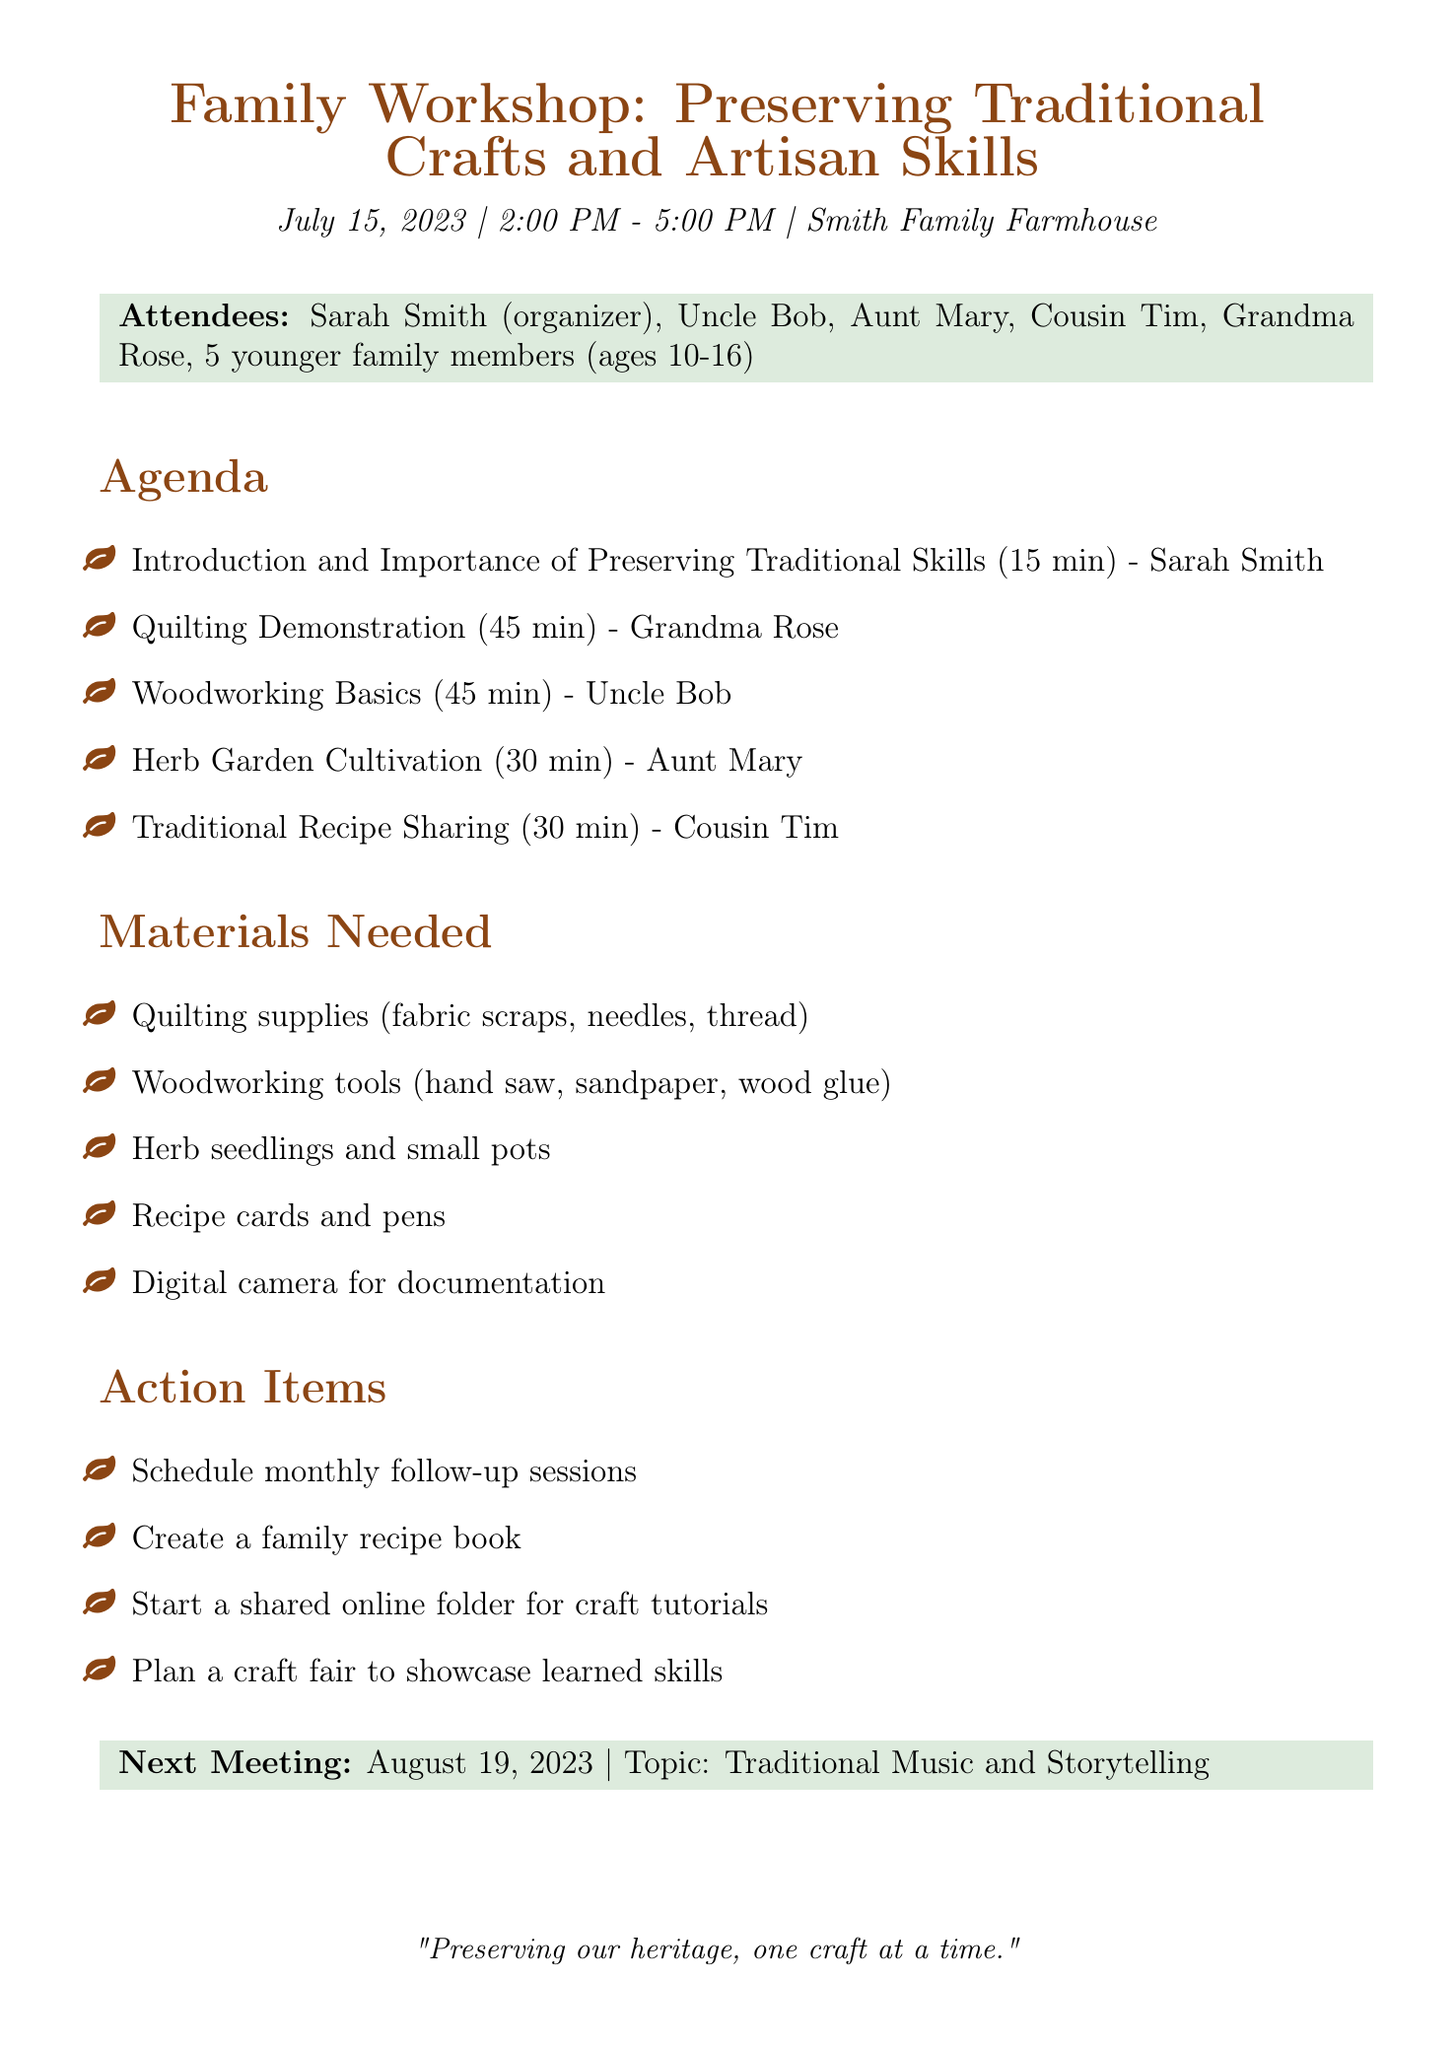What is the date of the workshop? The date of the workshop is specified in the document as July 15, 2023.
Answer: July 15, 2023 Who is the presenter for the Quilting Demonstration? The presenter for the Quilting Demonstration is mentioned as Grandma Rose.
Answer: Grandma Rose How long is the Woodworking Basics session? The duration of the Woodworking Basics session is given as 45 minutes.
Answer: 45 minutes What materials are needed for quilting? Quilting supplies required include fabric scraps, needles, and thread as listed in the materials needed section.
Answer: Fabric scraps, needles, thread What is one of the action items agreed upon during the meeting? One of the action items is to create a family recipe book, which is mentioned in the action items section.
Answer: Create a family recipe book How many younger family members attended the workshop? The number of younger family members is clearly stated as 5 in the attendees list.
Answer: 5 What is the location of the workshop? The location of the workshop is noted as Smith Family Farmhouse in the document.
Answer: Smith Family Farmhouse When is the next meeting scheduled? The document specifies that the next meeting is scheduled for August 19, 2023.
Answer: August 19, 2023 What topic will be discussed in the next meeting? The topic for the next meeting is mentioned as Traditional Music and Storytelling in the next meeting section.
Answer: Traditional Music and Storytelling 